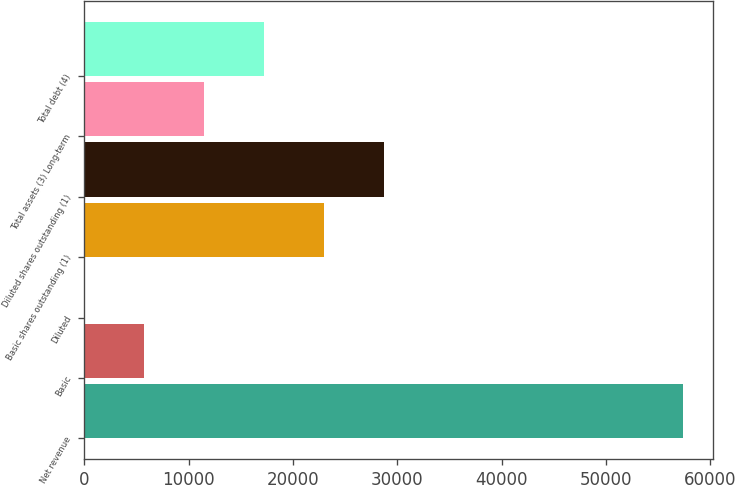Convert chart. <chart><loc_0><loc_0><loc_500><loc_500><bar_chart><fcel>Net revenue<fcel>Basic<fcel>Diluted<fcel>Basic shares outstanding (1)<fcel>Diluted shares outstanding (1)<fcel>Total assets (3) Long-term<fcel>Total debt (4)<nl><fcel>57371<fcel>5738.11<fcel>1.12<fcel>22949.1<fcel>28686.1<fcel>11475.1<fcel>17212.1<nl></chart> 